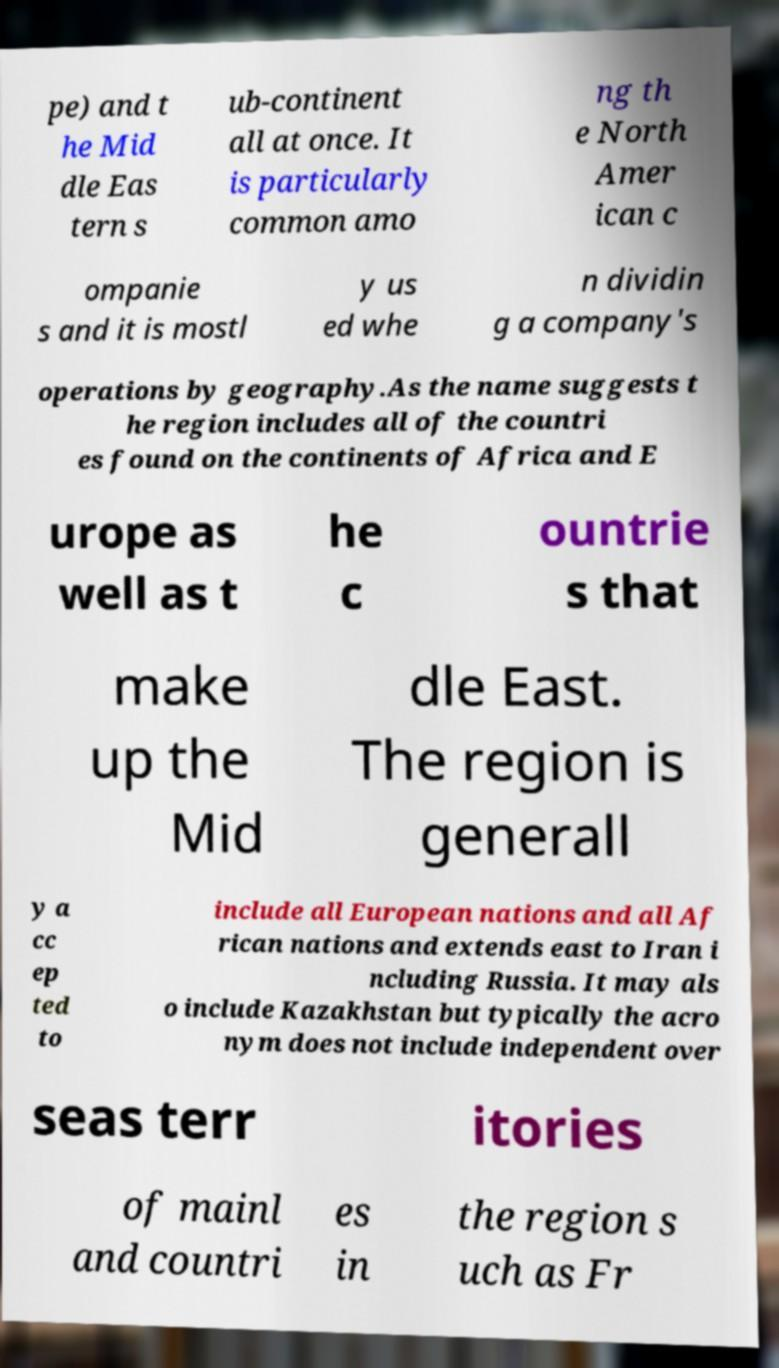There's text embedded in this image that I need extracted. Can you transcribe it verbatim? pe) and t he Mid dle Eas tern s ub-continent all at once. It is particularly common amo ng th e North Amer ican c ompanie s and it is mostl y us ed whe n dividin g a company's operations by geography.As the name suggests t he region includes all of the countri es found on the continents of Africa and E urope as well as t he c ountrie s that make up the Mid dle East. The region is generall y a cc ep ted to include all European nations and all Af rican nations and extends east to Iran i ncluding Russia. It may als o include Kazakhstan but typically the acro nym does not include independent over seas terr itories of mainl and countri es in the region s uch as Fr 